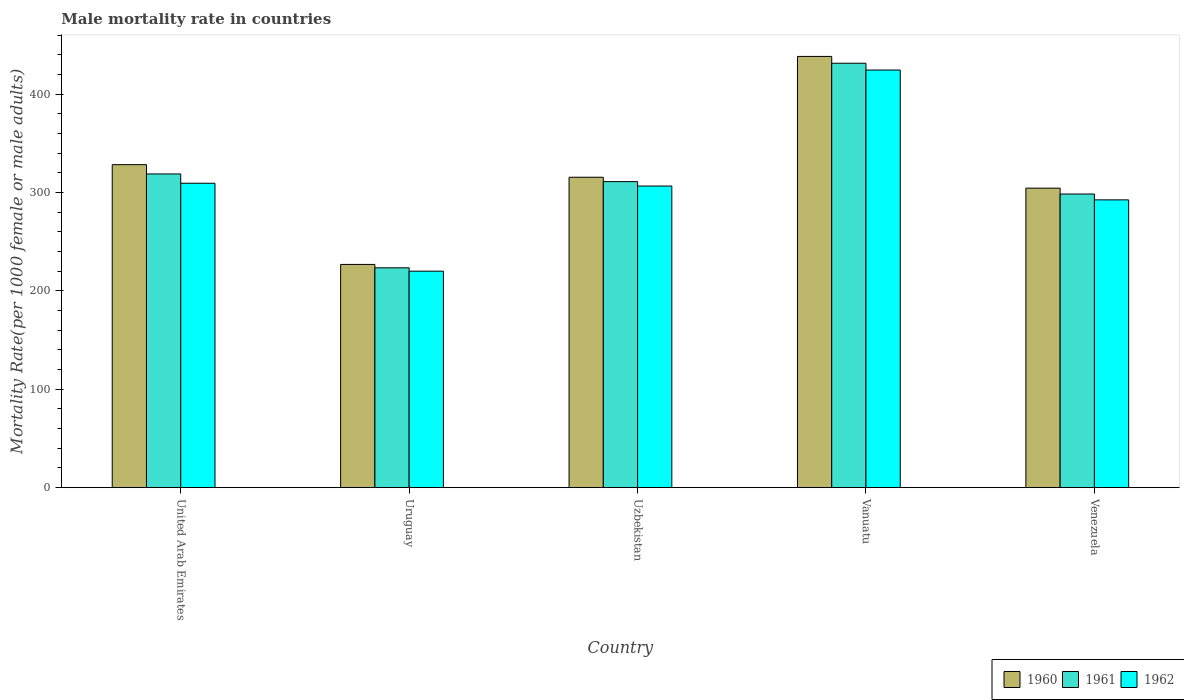How many groups of bars are there?
Your answer should be very brief. 5. Are the number of bars on each tick of the X-axis equal?
Provide a short and direct response. Yes. How many bars are there on the 2nd tick from the right?
Provide a succinct answer. 3. What is the label of the 5th group of bars from the left?
Provide a succinct answer. Venezuela. What is the male mortality rate in 1961 in Vanuatu?
Offer a terse response. 431.48. Across all countries, what is the maximum male mortality rate in 1960?
Your answer should be very brief. 438.4. Across all countries, what is the minimum male mortality rate in 1960?
Make the answer very short. 226.93. In which country was the male mortality rate in 1960 maximum?
Your response must be concise. Vanuatu. In which country was the male mortality rate in 1962 minimum?
Give a very brief answer. Uruguay. What is the total male mortality rate in 1962 in the graph?
Give a very brief answer. 1553.32. What is the difference between the male mortality rate in 1962 in Uzbekistan and that in Venezuela?
Provide a short and direct response. 14.06. What is the difference between the male mortality rate in 1960 in Vanuatu and the male mortality rate in 1961 in Venezuela?
Provide a short and direct response. 139.87. What is the average male mortality rate in 1962 per country?
Your answer should be very brief. 310.66. What is the difference between the male mortality rate of/in 1961 and male mortality rate of/in 1960 in Uzbekistan?
Your response must be concise. -4.48. In how many countries, is the male mortality rate in 1961 greater than 420?
Offer a very short reply. 1. What is the ratio of the male mortality rate in 1960 in Uruguay to that in Venezuela?
Keep it short and to the point. 0.75. What is the difference between the highest and the second highest male mortality rate in 1960?
Provide a short and direct response. 12.8. What is the difference between the highest and the lowest male mortality rate in 1962?
Give a very brief answer. 204.5. In how many countries, is the male mortality rate in 1961 greater than the average male mortality rate in 1961 taken over all countries?
Provide a short and direct response. 2. What does the 1st bar from the left in Uzbekistan represents?
Your response must be concise. 1960. Is it the case that in every country, the sum of the male mortality rate in 1962 and male mortality rate in 1960 is greater than the male mortality rate in 1961?
Your answer should be very brief. Yes. Are all the bars in the graph horizontal?
Provide a short and direct response. No. How many countries are there in the graph?
Offer a very short reply. 5. Does the graph contain any zero values?
Make the answer very short. No. Does the graph contain grids?
Offer a terse response. No. Where does the legend appear in the graph?
Provide a succinct answer. Bottom right. How are the legend labels stacked?
Offer a terse response. Horizontal. What is the title of the graph?
Provide a short and direct response. Male mortality rate in countries. Does "2008" appear as one of the legend labels in the graph?
Give a very brief answer. No. What is the label or title of the X-axis?
Give a very brief answer. Country. What is the label or title of the Y-axis?
Provide a succinct answer. Mortality Rate(per 1000 female or male adults). What is the Mortality Rate(per 1000 female or male adults) in 1960 in United Arab Emirates?
Keep it short and to the point. 328.38. What is the Mortality Rate(per 1000 female or male adults) in 1961 in United Arab Emirates?
Your answer should be compact. 318.93. What is the Mortality Rate(per 1000 female or male adults) of 1962 in United Arab Emirates?
Your answer should be compact. 309.48. What is the Mortality Rate(per 1000 female or male adults) of 1960 in Uruguay?
Provide a short and direct response. 226.93. What is the Mortality Rate(per 1000 female or male adults) of 1961 in Uruguay?
Give a very brief answer. 223.5. What is the Mortality Rate(per 1000 female or male adults) of 1962 in Uruguay?
Your response must be concise. 220.07. What is the Mortality Rate(per 1000 female or male adults) in 1960 in Uzbekistan?
Your answer should be very brief. 315.58. What is the Mortality Rate(per 1000 female or male adults) in 1961 in Uzbekistan?
Give a very brief answer. 311.11. What is the Mortality Rate(per 1000 female or male adults) of 1962 in Uzbekistan?
Make the answer very short. 306.63. What is the Mortality Rate(per 1000 female or male adults) in 1960 in Vanuatu?
Offer a terse response. 438.4. What is the Mortality Rate(per 1000 female or male adults) of 1961 in Vanuatu?
Provide a succinct answer. 431.48. What is the Mortality Rate(per 1000 female or male adults) of 1962 in Vanuatu?
Your answer should be compact. 424.57. What is the Mortality Rate(per 1000 female or male adults) in 1960 in Venezuela?
Your response must be concise. 304.49. What is the Mortality Rate(per 1000 female or male adults) of 1961 in Venezuela?
Offer a terse response. 298.53. What is the Mortality Rate(per 1000 female or male adults) in 1962 in Venezuela?
Your answer should be very brief. 292.57. Across all countries, what is the maximum Mortality Rate(per 1000 female or male adults) of 1960?
Make the answer very short. 438.4. Across all countries, what is the maximum Mortality Rate(per 1000 female or male adults) of 1961?
Provide a succinct answer. 431.48. Across all countries, what is the maximum Mortality Rate(per 1000 female or male adults) of 1962?
Provide a short and direct response. 424.57. Across all countries, what is the minimum Mortality Rate(per 1000 female or male adults) in 1960?
Offer a very short reply. 226.93. Across all countries, what is the minimum Mortality Rate(per 1000 female or male adults) of 1961?
Give a very brief answer. 223.5. Across all countries, what is the minimum Mortality Rate(per 1000 female or male adults) of 1962?
Keep it short and to the point. 220.07. What is the total Mortality Rate(per 1000 female or male adults) in 1960 in the graph?
Offer a very short reply. 1613.78. What is the total Mortality Rate(per 1000 female or male adults) of 1961 in the graph?
Your response must be concise. 1583.55. What is the total Mortality Rate(per 1000 female or male adults) of 1962 in the graph?
Make the answer very short. 1553.32. What is the difference between the Mortality Rate(per 1000 female or male adults) in 1960 in United Arab Emirates and that in Uruguay?
Offer a very short reply. 101.44. What is the difference between the Mortality Rate(per 1000 female or male adults) of 1961 in United Arab Emirates and that in Uruguay?
Provide a short and direct response. 95.43. What is the difference between the Mortality Rate(per 1000 female or male adults) of 1962 in United Arab Emirates and that in Uruguay?
Your response must be concise. 89.41. What is the difference between the Mortality Rate(per 1000 female or male adults) of 1960 in United Arab Emirates and that in Uzbekistan?
Ensure brevity in your answer.  12.8. What is the difference between the Mortality Rate(per 1000 female or male adults) of 1961 in United Arab Emirates and that in Uzbekistan?
Ensure brevity in your answer.  7.82. What is the difference between the Mortality Rate(per 1000 female or male adults) of 1962 in United Arab Emirates and that in Uzbekistan?
Your answer should be very brief. 2.85. What is the difference between the Mortality Rate(per 1000 female or male adults) of 1960 in United Arab Emirates and that in Vanuatu?
Provide a succinct answer. -110.02. What is the difference between the Mortality Rate(per 1000 female or male adults) of 1961 in United Arab Emirates and that in Vanuatu?
Ensure brevity in your answer.  -112.55. What is the difference between the Mortality Rate(per 1000 female or male adults) in 1962 in United Arab Emirates and that in Vanuatu?
Give a very brief answer. -115.09. What is the difference between the Mortality Rate(per 1000 female or male adults) of 1960 in United Arab Emirates and that in Venezuela?
Give a very brief answer. 23.89. What is the difference between the Mortality Rate(per 1000 female or male adults) of 1961 in United Arab Emirates and that in Venezuela?
Make the answer very short. 20.4. What is the difference between the Mortality Rate(per 1000 female or male adults) of 1962 in United Arab Emirates and that in Venezuela?
Make the answer very short. 16.91. What is the difference between the Mortality Rate(per 1000 female or male adults) in 1960 in Uruguay and that in Uzbekistan?
Offer a very short reply. -88.65. What is the difference between the Mortality Rate(per 1000 female or male adults) of 1961 in Uruguay and that in Uzbekistan?
Your answer should be compact. -87.6. What is the difference between the Mortality Rate(per 1000 female or male adults) in 1962 in Uruguay and that in Uzbekistan?
Your response must be concise. -86.56. What is the difference between the Mortality Rate(per 1000 female or male adults) of 1960 in Uruguay and that in Vanuatu?
Your answer should be very brief. -211.47. What is the difference between the Mortality Rate(per 1000 female or male adults) in 1961 in Uruguay and that in Vanuatu?
Your response must be concise. -207.98. What is the difference between the Mortality Rate(per 1000 female or male adults) of 1962 in Uruguay and that in Vanuatu?
Your answer should be very brief. -204.5. What is the difference between the Mortality Rate(per 1000 female or male adults) in 1960 in Uruguay and that in Venezuela?
Offer a terse response. -77.55. What is the difference between the Mortality Rate(per 1000 female or male adults) of 1961 in Uruguay and that in Venezuela?
Make the answer very short. -75.03. What is the difference between the Mortality Rate(per 1000 female or male adults) in 1962 in Uruguay and that in Venezuela?
Make the answer very short. -72.5. What is the difference between the Mortality Rate(per 1000 female or male adults) in 1960 in Uzbekistan and that in Vanuatu?
Provide a succinct answer. -122.82. What is the difference between the Mortality Rate(per 1000 female or male adults) of 1961 in Uzbekistan and that in Vanuatu?
Make the answer very short. -120.38. What is the difference between the Mortality Rate(per 1000 female or male adults) of 1962 in Uzbekistan and that in Vanuatu?
Offer a terse response. -117.94. What is the difference between the Mortality Rate(per 1000 female or male adults) in 1960 in Uzbekistan and that in Venezuela?
Your response must be concise. 11.1. What is the difference between the Mortality Rate(per 1000 female or male adults) of 1961 in Uzbekistan and that in Venezuela?
Ensure brevity in your answer.  12.58. What is the difference between the Mortality Rate(per 1000 female or male adults) in 1962 in Uzbekistan and that in Venezuela?
Make the answer very short. 14.06. What is the difference between the Mortality Rate(per 1000 female or male adults) of 1960 in Vanuatu and that in Venezuela?
Provide a succinct answer. 133.91. What is the difference between the Mortality Rate(per 1000 female or male adults) in 1961 in Vanuatu and that in Venezuela?
Offer a very short reply. 132.96. What is the difference between the Mortality Rate(per 1000 female or male adults) of 1962 in Vanuatu and that in Venezuela?
Provide a succinct answer. 132. What is the difference between the Mortality Rate(per 1000 female or male adults) in 1960 in United Arab Emirates and the Mortality Rate(per 1000 female or male adults) in 1961 in Uruguay?
Your answer should be compact. 104.88. What is the difference between the Mortality Rate(per 1000 female or male adults) in 1960 in United Arab Emirates and the Mortality Rate(per 1000 female or male adults) in 1962 in Uruguay?
Your response must be concise. 108.31. What is the difference between the Mortality Rate(per 1000 female or male adults) of 1961 in United Arab Emirates and the Mortality Rate(per 1000 female or male adults) of 1962 in Uruguay?
Offer a terse response. 98.86. What is the difference between the Mortality Rate(per 1000 female or male adults) in 1960 in United Arab Emirates and the Mortality Rate(per 1000 female or male adults) in 1961 in Uzbekistan?
Your response must be concise. 17.27. What is the difference between the Mortality Rate(per 1000 female or male adults) of 1960 in United Arab Emirates and the Mortality Rate(per 1000 female or male adults) of 1962 in Uzbekistan?
Your response must be concise. 21.75. What is the difference between the Mortality Rate(per 1000 female or male adults) of 1961 in United Arab Emirates and the Mortality Rate(per 1000 female or male adults) of 1962 in Uzbekistan?
Give a very brief answer. 12.3. What is the difference between the Mortality Rate(per 1000 female or male adults) of 1960 in United Arab Emirates and the Mortality Rate(per 1000 female or male adults) of 1961 in Vanuatu?
Keep it short and to the point. -103.11. What is the difference between the Mortality Rate(per 1000 female or male adults) in 1960 in United Arab Emirates and the Mortality Rate(per 1000 female or male adults) in 1962 in Vanuatu?
Give a very brief answer. -96.19. What is the difference between the Mortality Rate(per 1000 female or male adults) in 1961 in United Arab Emirates and the Mortality Rate(per 1000 female or male adults) in 1962 in Vanuatu?
Provide a succinct answer. -105.64. What is the difference between the Mortality Rate(per 1000 female or male adults) in 1960 in United Arab Emirates and the Mortality Rate(per 1000 female or male adults) in 1961 in Venezuela?
Ensure brevity in your answer.  29.85. What is the difference between the Mortality Rate(per 1000 female or male adults) of 1960 in United Arab Emirates and the Mortality Rate(per 1000 female or male adults) of 1962 in Venezuela?
Give a very brief answer. 35.81. What is the difference between the Mortality Rate(per 1000 female or male adults) in 1961 in United Arab Emirates and the Mortality Rate(per 1000 female or male adults) in 1962 in Venezuela?
Provide a short and direct response. 26.36. What is the difference between the Mortality Rate(per 1000 female or male adults) of 1960 in Uruguay and the Mortality Rate(per 1000 female or male adults) of 1961 in Uzbekistan?
Keep it short and to the point. -84.17. What is the difference between the Mortality Rate(per 1000 female or male adults) of 1960 in Uruguay and the Mortality Rate(per 1000 female or male adults) of 1962 in Uzbekistan?
Your answer should be very brief. -79.7. What is the difference between the Mortality Rate(per 1000 female or male adults) in 1961 in Uruguay and the Mortality Rate(per 1000 female or male adults) in 1962 in Uzbekistan?
Ensure brevity in your answer.  -83.13. What is the difference between the Mortality Rate(per 1000 female or male adults) in 1960 in Uruguay and the Mortality Rate(per 1000 female or male adults) in 1961 in Vanuatu?
Give a very brief answer. -204.55. What is the difference between the Mortality Rate(per 1000 female or male adults) in 1960 in Uruguay and the Mortality Rate(per 1000 female or male adults) in 1962 in Vanuatu?
Your answer should be very brief. -197.64. What is the difference between the Mortality Rate(per 1000 female or male adults) in 1961 in Uruguay and the Mortality Rate(per 1000 female or male adults) in 1962 in Vanuatu?
Offer a terse response. -201.07. What is the difference between the Mortality Rate(per 1000 female or male adults) of 1960 in Uruguay and the Mortality Rate(per 1000 female or male adults) of 1961 in Venezuela?
Offer a very short reply. -71.59. What is the difference between the Mortality Rate(per 1000 female or male adults) of 1960 in Uruguay and the Mortality Rate(per 1000 female or male adults) of 1962 in Venezuela?
Offer a terse response. -65.64. What is the difference between the Mortality Rate(per 1000 female or male adults) of 1961 in Uruguay and the Mortality Rate(per 1000 female or male adults) of 1962 in Venezuela?
Give a very brief answer. -69.07. What is the difference between the Mortality Rate(per 1000 female or male adults) in 1960 in Uzbekistan and the Mortality Rate(per 1000 female or male adults) in 1961 in Vanuatu?
Your answer should be very brief. -115.9. What is the difference between the Mortality Rate(per 1000 female or male adults) in 1960 in Uzbekistan and the Mortality Rate(per 1000 female or male adults) in 1962 in Vanuatu?
Your response must be concise. -108.99. What is the difference between the Mortality Rate(per 1000 female or male adults) of 1961 in Uzbekistan and the Mortality Rate(per 1000 female or male adults) of 1962 in Vanuatu?
Offer a terse response. -113.46. What is the difference between the Mortality Rate(per 1000 female or male adults) of 1960 in Uzbekistan and the Mortality Rate(per 1000 female or male adults) of 1961 in Venezuela?
Offer a terse response. 17.05. What is the difference between the Mortality Rate(per 1000 female or male adults) in 1960 in Uzbekistan and the Mortality Rate(per 1000 female or male adults) in 1962 in Venezuela?
Offer a terse response. 23.01. What is the difference between the Mortality Rate(per 1000 female or male adults) of 1961 in Uzbekistan and the Mortality Rate(per 1000 female or male adults) of 1962 in Venezuela?
Provide a succinct answer. 18.54. What is the difference between the Mortality Rate(per 1000 female or male adults) of 1960 in Vanuatu and the Mortality Rate(per 1000 female or male adults) of 1961 in Venezuela?
Offer a terse response. 139.87. What is the difference between the Mortality Rate(per 1000 female or male adults) in 1960 in Vanuatu and the Mortality Rate(per 1000 female or male adults) in 1962 in Venezuela?
Ensure brevity in your answer.  145.83. What is the difference between the Mortality Rate(per 1000 female or male adults) of 1961 in Vanuatu and the Mortality Rate(per 1000 female or male adults) of 1962 in Venezuela?
Ensure brevity in your answer.  138.91. What is the average Mortality Rate(per 1000 female or male adults) in 1960 per country?
Make the answer very short. 322.76. What is the average Mortality Rate(per 1000 female or male adults) in 1961 per country?
Offer a terse response. 316.71. What is the average Mortality Rate(per 1000 female or male adults) of 1962 per country?
Make the answer very short. 310.66. What is the difference between the Mortality Rate(per 1000 female or male adults) of 1960 and Mortality Rate(per 1000 female or male adults) of 1961 in United Arab Emirates?
Give a very brief answer. 9.45. What is the difference between the Mortality Rate(per 1000 female or male adults) of 1960 and Mortality Rate(per 1000 female or male adults) of 1962 in United Arab Emirates?
Ensure brevity in your answer.  18.9. What is the difference between the Mortality Rate(per 1000 female or male adults) of 1961 and Mortality Rate(per 1000 female or male adults) of 1962 in United Arab Emirates?
Your answer should be compact. 9.45. What is the difference between the Mortality Rate(per 1000 female or male adults) in 1960 and Mortality Rate(per 1000 female or male adults) in 1961 in Uruguay?
Your answer should be very brief. 3.43. What is the difference between the Mortality Rate(per 1000 female or male adults) in 1960 and Mortality Rate(per 1000 female or male adults) in 1962 in Uruguay?
Provide a short and direct response. 6.86. What is the difference between the Mortality Rate(per 1000 female or male adults) of 1961 and Mortality Rate(per 1000 female or male adults) of 1962 in Uruguay?
Your answer should be very brief. 3.43. What is the difference between the Mortality Rate(per 1000 female or male adults) of 1960 and Mortality Rate(per 1000 female or male adults) of 1961 in Uzbekistan?
Offer a terse response. 4.48. What is the difference between the Mortality Rate(per 1000 female or male adults) of 1960 and Mortality Rate(per 1000 female or male adults) of 1962 in Uzbekistan?
Offer a terse response. 8.95. What is the difference between the Mortality Rate(per 1000 female or male adults) of 1961 and Mortality Rate(per 1000 female or male adults) of 1962 in Uzbekistan?
Your answer should be compact. 4.48. What is the difference between the Mortality Rate(per 1000 female or male adults) of 1960 and Mortality Rate(per 1000 female or male adults) of 1961 in Vanuatu?
Provide a succinct answer. 6.91. What is the difference between the Mortality Rate(per 1000 female or male adults) of 1960 and Mortality Rate(per 1000 female or male adults) of 1962 in Vanuatu?
Ensure brevity in your answer.  13.83. What is the difference between the Mortality Rate(per 1000 female or male adults) of 1961 and Mortality Rate(per 1000 female or male adults) of 1962 in Vanuatu?
Offer a terse response. 6.91. What is the difference between the Mortality Rate(per 1000 female or male adults) of 1960 and Mortality Rate(per 1000 female or male adults) of 1961 in Venezuela?
Your response must be concise. 5.96. What is the difference between the Mortality Rate(per 1000 female or male adults) in 1960 and Mortality Rate(per 1000 female or male adults) in 1962 in Venezuela?
Offer a very short reply. 11.92. What is the difference between the Mortality Rate(per 1000 female or male adults) in 1961 and Mortality Rate(per 1000 female or male adults) in 1962 in Venezuela?
Ensure brevity in your answer.  5.96. What is the ratio of the Mortality Rate(per 1000 female or male adults) in 1960 in United Arab Emirates to that in Uruguay?
Provide a succinct answer. 1.45. What is the ratio of the Mortality Rate(per 1000 female or male adults) of 1961 in United Arab Emirates to that in Uruguay?
Your response must be concise. 1.43. What is the ratio of the Mortality Rate(per 1000 female or male adults) in 1962 in United Arab Emirates to that in Uruguay?
Offer a very short reply. 1.41. What is the ratio of the Mortality Rate(per 1000 female or male adults) in 1960 in United Arab Emirates to that in Uzbekistan?
Make the answer very short. 1.04. What is the ratio of the Mortality Rate(per 1000 female or male adults) of 1961 in United Arab Emirates to that in Uzbekistan?
Give a very brief answer. 1.03. What is the ratio of the Mortality Rate(per 1000 female or male adults) of 1962 in United Arab Emirates to that in Uzbekistan?
Your answer should be very brief. 1.01. What is the ratio of the Mortality Rate(per 1000 female or male adults) in 1960 in United Arab Emirates to that in Vanuatu?
Keep it short and to the point. 0.75. What is the ratio of the Mortality Rate(per 1000 female or male adults) in 1961 in United Arab Emirates to that in Vanuatu?
Your answer should be very brief. 0.74. What is the ratio of the Mortality Rate(per 1000 female or male adults) of 1962 in United Arab Emirates to that in Vanuatu?
Provide a short and direct response. 0.73. What is the ratio of the Mortality Rate(per 1000 female or male adults) in 1960 in United Arab Emirates to that in Venezuela?
Provide a short and direct response. 1.08. What is the ratio of the Mortality Rate(per 1000 female or male adults) in 1961 in United Arab Emirates to that in Venezuela?
Ensure brevity in your answer.  1.07. What is the ratio of the Mortality Rate(per 1000 female or male adults) of 1962 in United Arab Emirates to that in Venezuela?
Ensure brevity in your answer.  1.06. What is the ratio of the Mortality Rate(per 1000 female or male adults) of 1960 in Uruguay to that in Uzbekistan?
Offer a very short reply. 0.72. What is the ratio of the Mortality Rate(per 1000 female or male adults) in 1961 in Uruguay to that in Uzbekistan?
Your answer should be very brief. 0.72. What is the ratio of the Mortality Rate(per 1000 female or male adults) of 1962 in Uruguay to that in Uzbekistan?
Offer a terse response. 0.72. What is the ratio of the Mortality Rate(per 1000 female or male adults) of 1960 in Uruguay to that in Vanuatu?
Offer a terse response. 0.52. What is the ratio of the Mortality Rate(per 1000 female or male adults) of 1961 in Uruguay to that in Vanuatu?
Your answer should be compact. 0.52. What is the ratio of the Mortality Rate(per 1000 female or male adults) of 1962 in Uruguay to that in Vanuatu?
Make the answer very short. 0.52. What is the ratio of the Mortality Rate(per 1000 female or male adults) in 1960 in Uruguay to that in Venezuela?
Offer a very short reply. 0.75. What is the ratio of the Mortality Rate(per 1000 female or male adults) in 1961 in Uruguay to that in Venezuela?
Offer a terse response. 0.75. What is the ratio of the Mortality Rate(per 1000 female or male adults) in 1962 in Uruguay to that in Venezuela?
Keep it short and to the point. 0.75. What is the ratio of the Mortality Rate(per 1000 female or male adults) in 1960 in Uzbekistan to that in Vanuatu?
Ensure brevity in your answer.  0.72. What is the ratio of the Mortality Rate(per 1000 female or male adults) of 1961 in Uzbekistan to that in Vanuatu?
Keep it short and to the point. 0.72. What is the ratio of the Mortality Rate(per 1000 female or male adults) in 1962 in Uzbekistan to that in Vanuatu?
Your answer should be compact. 0.72. What is the ratio of the Mortality Rate(per 1000 female or male adults) in 1960 in Uzbekistan to that in Venezuela?
Offer a very short reply. 1.04. What is the ratio of the Mortality Rate(per 1000 female or male adults) in 1961 in Uzbekistan to that in Venezuela?
Ensure brevity in your answer.  1.04. What is the ratio of the Mortality Rate(per 1000 female or male adults) of 1962 in Uzbekistan to that in Venezuela?
Provide a short and direct response. 1.05. What is the ratio of the Mortality Rate(per 1000 female or male adults) of 1960 in Vanuatu to that in Venezuela?
Your answer should be very brief. 1.44. What is the ratio of the Mortality Rate(per 1000 female or male adults) in 1961 in Vanuatu to that in Venezuela?
Offer a terse response. 1.45. What is the ratio of the Mortality Rate(per 1000 female or male adults) of 1962 in Vanuatu to that in Venezuela?
Ensure brevity in your answer.  1.45. What is the difference between the highest and the second highest Mortality Rate(per 1000 female or male adults) in 1960?
Provide a short and direct response. 110.02. What is the difference between the highest and the second highest Mortality Rate(per 1000 female or male adults) in 1961?
Your response must be concise. 112.55. What is the difference between the highest and the second highest Mortality Rate(per 1000 female or male adults) of 1962?
Offer a terse response. 115.09. What is the difference between the highest and the lowest Mortality Rate(per 1000 female or male adults) in 1960?
Provide a short and direct response. 211.47. What is the difference between the highest and the lowest Mortality Rate(per 1000 female or male adults) in 1961?
Make the answer very short. 207.98. What is the difference between the highest and the lowest Mortality Rate(per 1000 female or male adults) in 1962?
Your answer should be very brief. 204.5. 